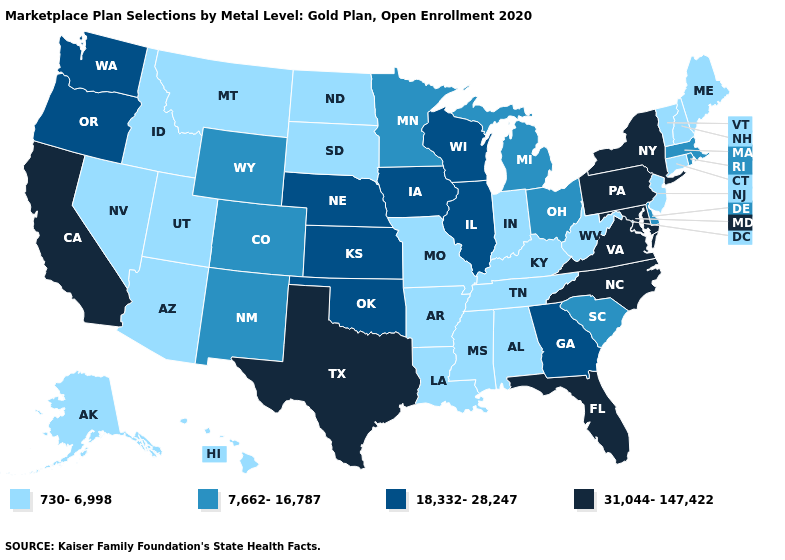Which states hav the highest value in the MidWest?
Be succinct. Illinois, Iowa, Kansas, Nebraska, Wisconsin. Which states have the lowest value in the Northeast?
Be succinct. Connecticut, Maine, New Hampshire, New Jersey, Vermont. Does North Dakota have the lowest value in the USA?
Give a very brief answer. Yes. How many symbols are there in the legend?
Quick response, please. 4. Among the states that border Alabama , which have the highest value?
Write a very short answer. Florida. What is the value of North Dakota?
Give a very brief answer. 730-6,998. Among the states that border Kansas , does Oklahoma have the highest value?
Concise answer only. Yes. What is the highest value in states that border New Hampshire?
Be succinct. 7,662-16,787. What is the highest value in the USA?
Quick response, please. 31,044-147,422. What is the value of Montana?
Quick response, please. 730-6,998. Name the states that have a value in the range 7,662-16,787?
Answer briefly. Colorado, Delaware, Massachusetts, Michigan, Minnesota, New Mexico, Ohio, Rhode Island, South Carolina, Wyoming. Name the states that have a value in the range 18,332-28,247?
Quick response, please. Georgia, Illinois, Iowa, Kansas, Nebraska, Oklahoma, Oregon, Washington, Wisconsin. Does Vermont have the lowest value in the USA?
Keep it brief. Yes. Does Louisiana have the lowest value in the USA?
Concise answer only. Yes. Which states have the lowest value in the USA?
Be succinct. Alabama, Alaska, Arizona, Arkansas, Connecticut, Hawaii, Idaho, Indiana, Kentucky, Louisiana, Maine, Mississippi, Missouri, Montana, Nevada, New Hampshire, New Jersey, North Dakota, South Dakota, Tennessee, Utah, Vermont, West Virginia. 